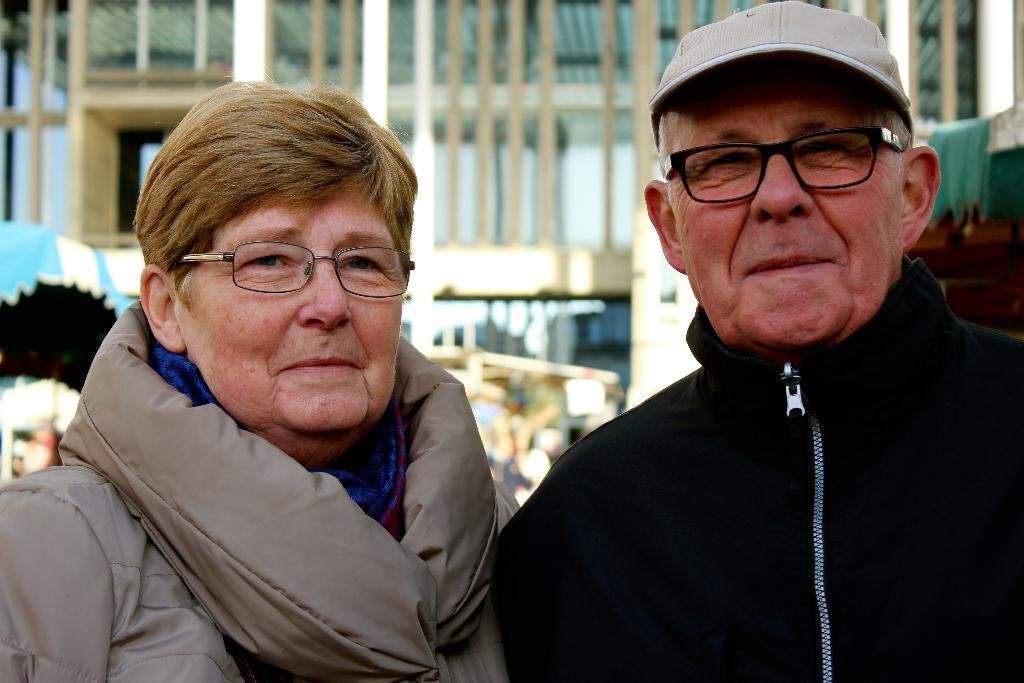How many people are in the image? There are two people standing in the image. What is located behind the people? There are a few stalls behind the people. What can be seen in the distance in the image? There is a building visible in the background. What is the opinion of the silver object on the people's conversation? There is no silver object present in the image, and therefore it cannot have an opinion on the people's conversation. 